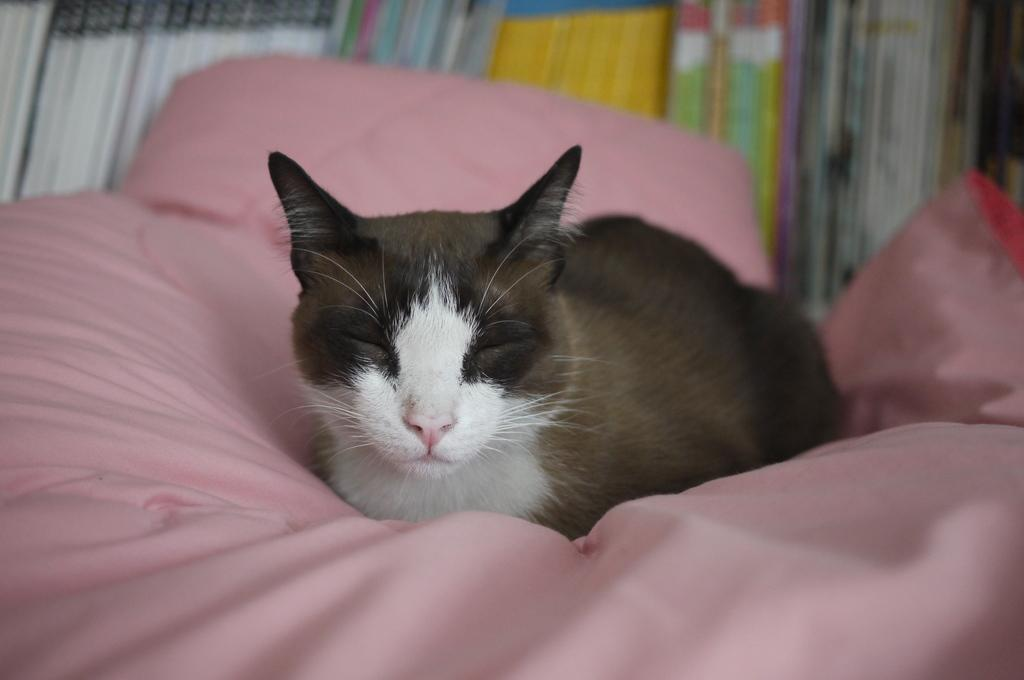What animal is present in the image? There is a cat in the image. Where is the cat located? The cat is on a pink cloth. What else can be seen in the background of the image? There are books in the background of the image. How many kittens are playing with the cat on the floor in the image? There are no kittens present in the image, and the cat is not on the floor but on a pink cloth. 